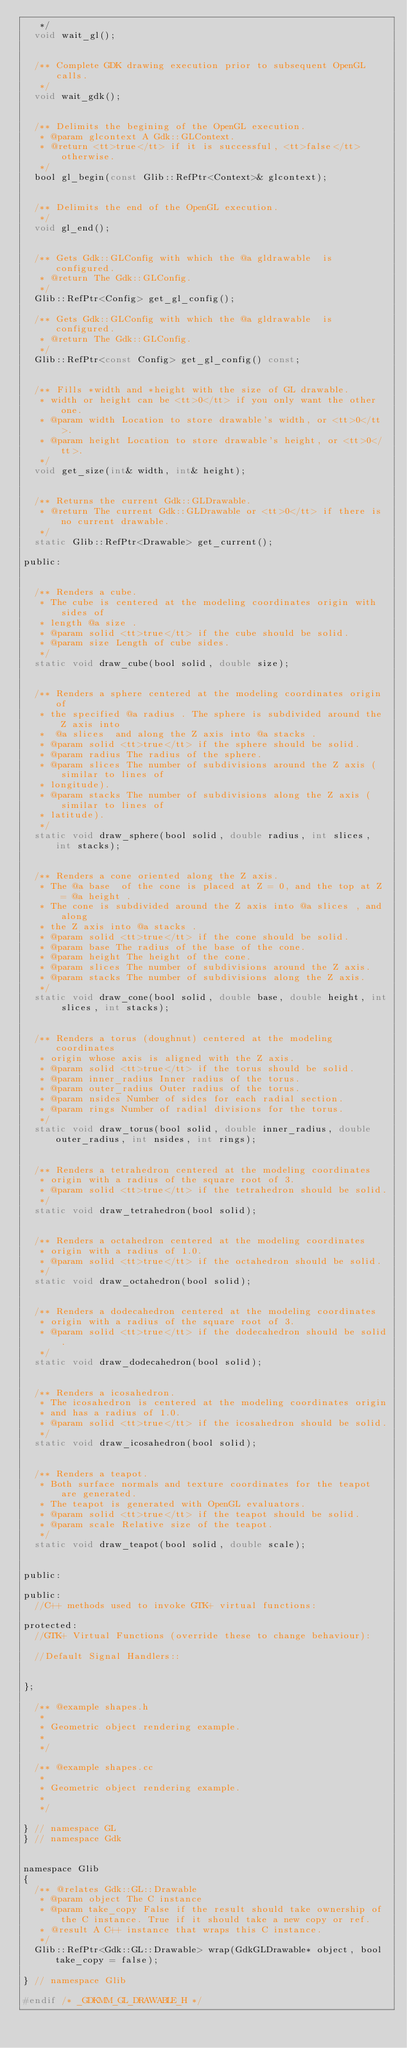<code> <loc_0><loc_0><loc_500><loc_500><_C_>   */
  void wait_gl();

  
  /** Complete GDK drawing execution prior to subsequent OpenGL calls.
   */
  void wait_gdk();

  
  /** Delimits the begining of the OpenGL execution.
   * @param glcontext A Gdk::GLContext.
   * @return <tt>true</tt> if it is successful, <tt>false</tt> otherwise.
   */
  bool gl_begin(const Glib::RefPtr<Context>& glcontext);

  
  /** Delimits the end of the OpenGL execution.
   */
  void gl_end();

  
  /** Gets Gdk::GLConfig with which the @a gldrawable  is configured.
   * @return The Gdk::GLConfig.
   */
  Glib::RefPtr<Config> get_gl_config();
  
  /** Gets Gdk::GLConfig with which the @a gldrawable  is configured.
   * @return The Gdk::GLConfig.
   */
  Glib::RefPtr<const Config> get_gl_config() const;

  
  /** Fills *width and *height with the size of GL drawable.
   * width or height can be <tt>0</tt> if you only want the other one.
   * @param width Location to store drawable's width, or <tt>0</tt>.
   * @param height Location to store drawable's height, or <tt>0</tt>.
   */
  void get_size(int& width, int& height);

  
  /** Returns the current Gdk::GLDrawable.
   * @return The current Gdk::GLDrawable or <tt>0</tt> if there is no current drawable.
   */
  static Glib::RefPtr<Drawable> get_current();

public:

  
  /** Renders a cube.
   * The cube is centered at the modeling coordinates origin with sides of
   * length @a size .
   * @param solid <tt>true</tt> if the cube should be solid.
   * @param size Length of cube sides.
   */
  static void draw_cube(bool solid, double size);

  
  /** Renders a sphere centered at the modeling coordinates origin of
   * the specified @a radius . The sphere is subdivided around the Z axis into
   *  @a slices  and along the Z axis into @a stacks .
   * @param solid <tt>true</tt> if the sphere should be solid.
   * @param radius The radius of the sphere.
   * @param slices The number of subdivisions around the Z axis (similar to lines of
   * longitude).
   * @param stacks The number of subdivisions along the Z axis (similar to lines of
   * latitude).
   */
  static void draw_sphere(bool solid, double radius, int slices, int stacks);

  
  /** Renders a cone oriented along the Z axis.
   * The @a base  of the cone is placed at Z = 0, and the top at Z = @a height .
   * The cone is subdivided around the Z axis into @a slices , and along
   * the Z axis into @a stacks .
   * @param solid <tt>true</tt> if the cone should be solid.
   * @param base The radius of the base of the cone.
   * @param height The height of the cone.
   * @param slices The number of subdivisions around the Z axis.
   * @param stacks The number of subdivisions along the Z axis.
   */
  static void draw_cone(bool solid, double base, double height, int slices, int stacks);

  
  /** Renders a torus (doughnut) centered at the modeling coordinates
   * origin whose axis is aligned with the Z axis.
   * @param solid <tt>true</tt> if the torus should be solid.
   * @param inner_radius Inner radius of the torus.
   * @param outer_radius Outer radius of the torus.
   * @param nsides Number of sides for each radial section.
   * @param rings Number of radial divisions for the torus.
   */
  static void draw_torus(bool solid, double inner_radius, double outer_radius, int nsides, int rings);

  
  /** Renders a tetrahedron centered at the modeling coordinates
   * origin with a radius of the square root of 3.
   * @param solid <tt>true</tt> if the tetrahedron should be solid.
   */
  static void draw_tetrahedron(bool solid);

  
  /** Renders a octahedron centered at the modeling coordinates
   * origin with a radius of 1.0.
   * @param solid <tt>true</tt> if the octahedron should be solid.
   */
  static void draw_octahedron(bool solid);

  
  /** Renders a dodecahedron centered at the modeling coordinates
   * origin with a radius of the square root of 3.
   * @param solid <tt>true</tt> if the dodecahedron should be solid.
   */
  static void draw_dodecahedron(bool solid);

  
  /** Renders a icosahedron.
   * The icosahedron is centered at the modeling coordinates origin
   * and has a radius of 1.0.
   * @param solid <tt>true</tt> if the icosahedron should be solid.
   */
  static void draw_icosahedron(bool solid);

  
  /** Renders a teapot.
   * Both surface normals and texture coordinates for the teapot are generated.
   * The teapot is generated with OpenGL evaluators.
   * @param solid <tt>true</tt> if the teapot should be solid.
   * @param scale Relative size of the teapot.
   */
  static void draw_teapot(bool solid, double scale);


public:

public:
  //C++ methods used to invoke GTK+ virtual functions:

protected:
  //GTK+ Virtual Functions (override these to change behaviour):

  //Default Signal Handlers::


};

  /** @example shapes.h
   *
   * Geometric object rendering example.
   *
   */

  /** @example shapes.cc
   *
   * Geometric object rendering example.
   *
   */

} // namespace GL
} // namespace Gdk


namespace Glib
{
  /** @relates Gdk::GL::Drawable
   * @param object The C instance
   * @param take_copy False if the result should take ownership of the C instance. True if it should take a new copy or ref.
   * @result A C++ instance that wraps this C instance.
   */
  Glib::RefPtr<Gdk::GL::Drawable> wrap(GdkGLDrawable* object, bool take_copy = false);

} // namespace Glib

#endif /* _GDKMM_GL_DRAWABLE_H */

</code> 